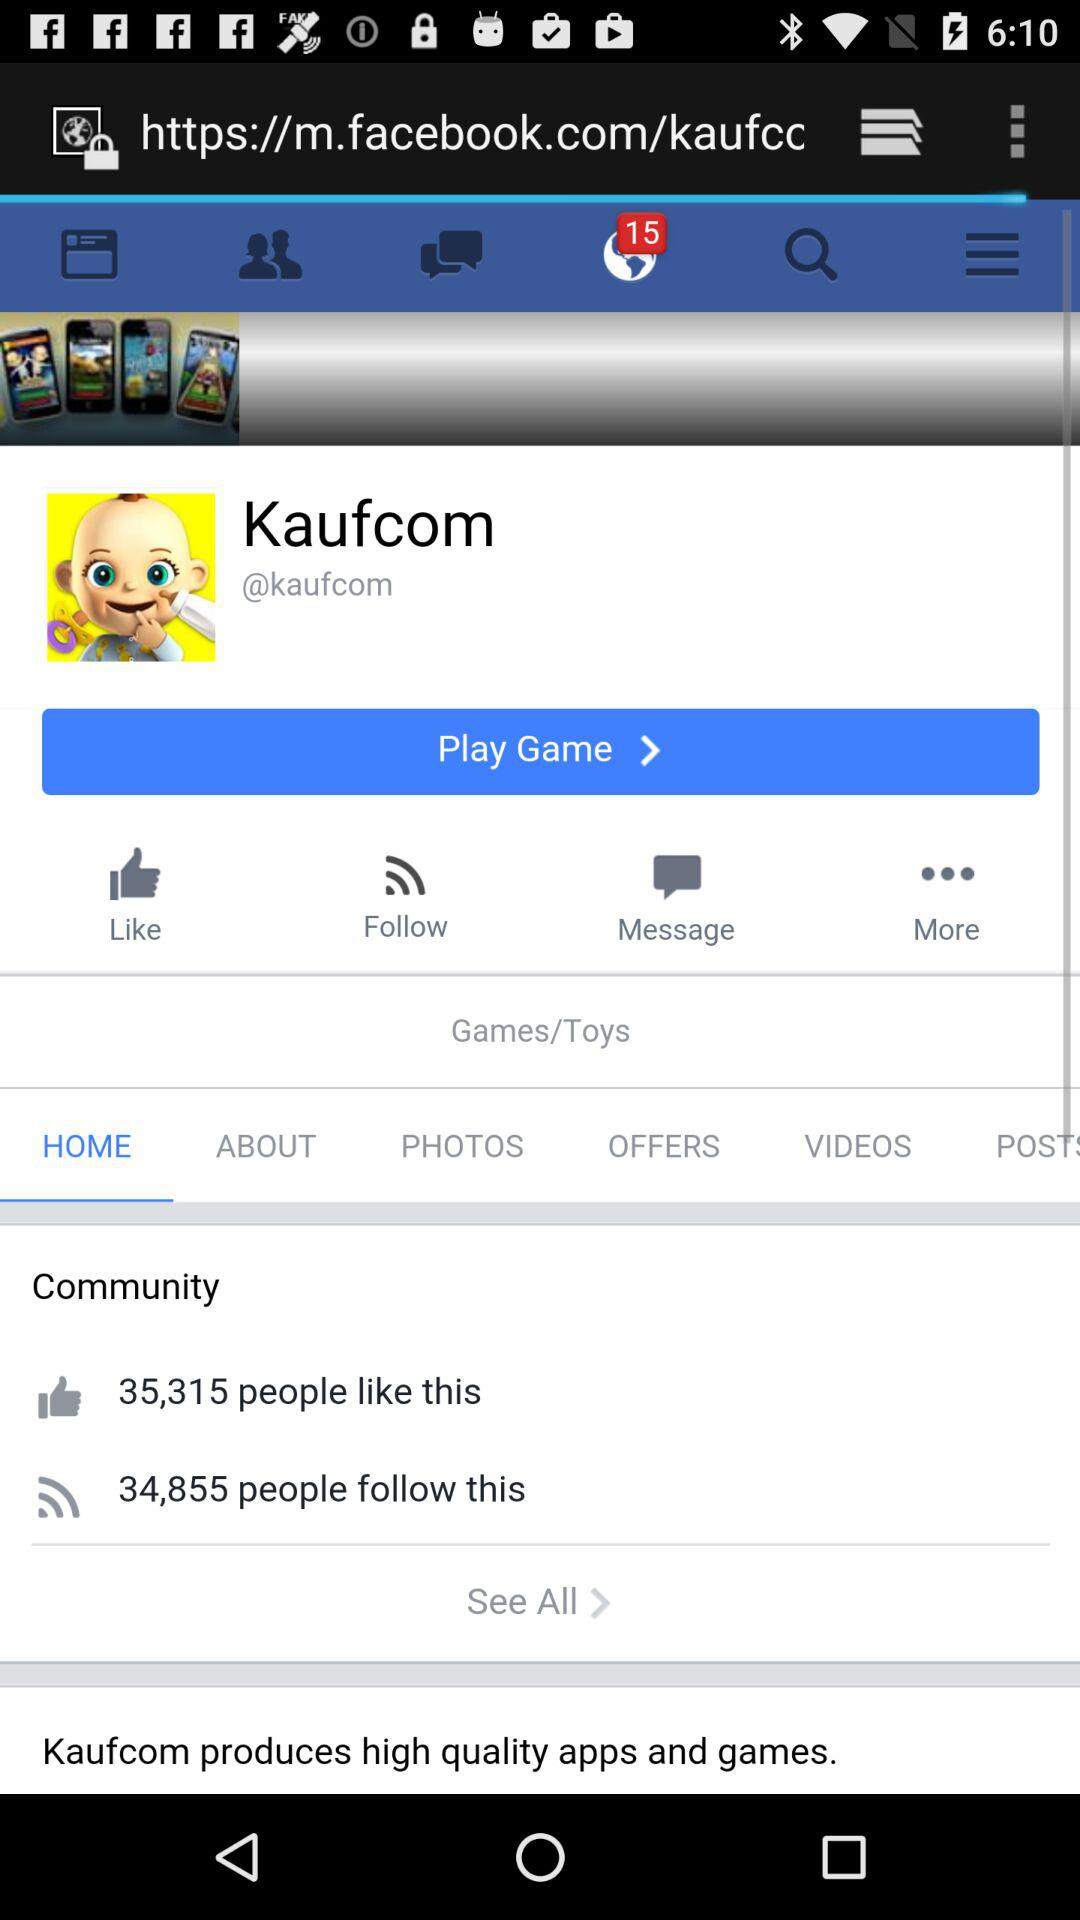How many notifications are there? There are 15 notifications. 